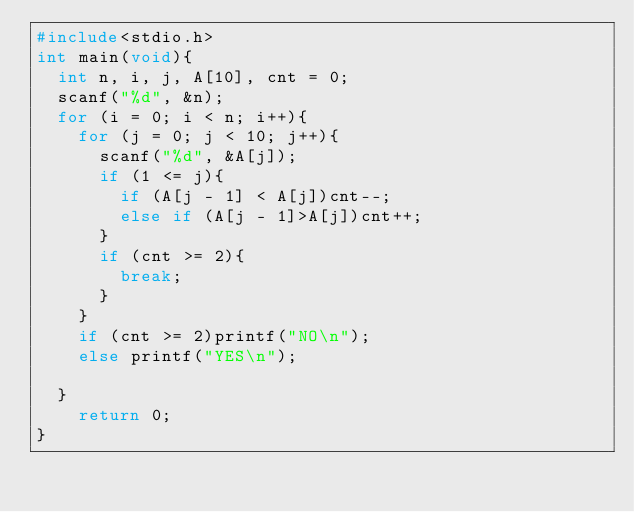Convert code to text. <code><loc_0><loc_0><loc_500><loc_500><_C_>#include<stdio.h>
int main(void){
	int n, i, j, A[10], cnt = 0;
	scanf("%d", &n);
	for (i = 0; i < n; i++){
		for (j = 0; j < 10; j++){
			scanf("%d", &A[j]);
			if (1 <= j){
				if (A[j - 1] < A[j])cnt--;
				else if (A[j - 1]>A[j])cnt++;
			}
			if (cnt >= 2){
				break;
			}
		}
		if (cnt >= 2)printf("NO\n");
		else printf("YES\n");
		
	}
    return 0;
}</code> 